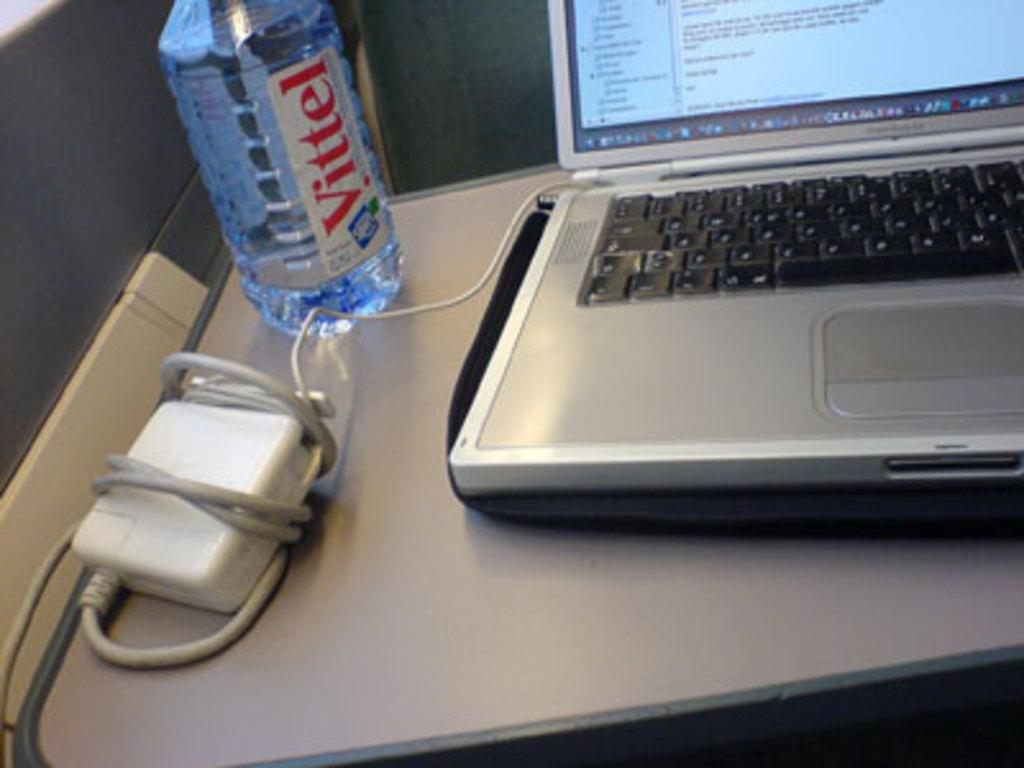Provide a one-sentence caption for the provided image. Water bottle of Vitel next to a laptop on a table. 